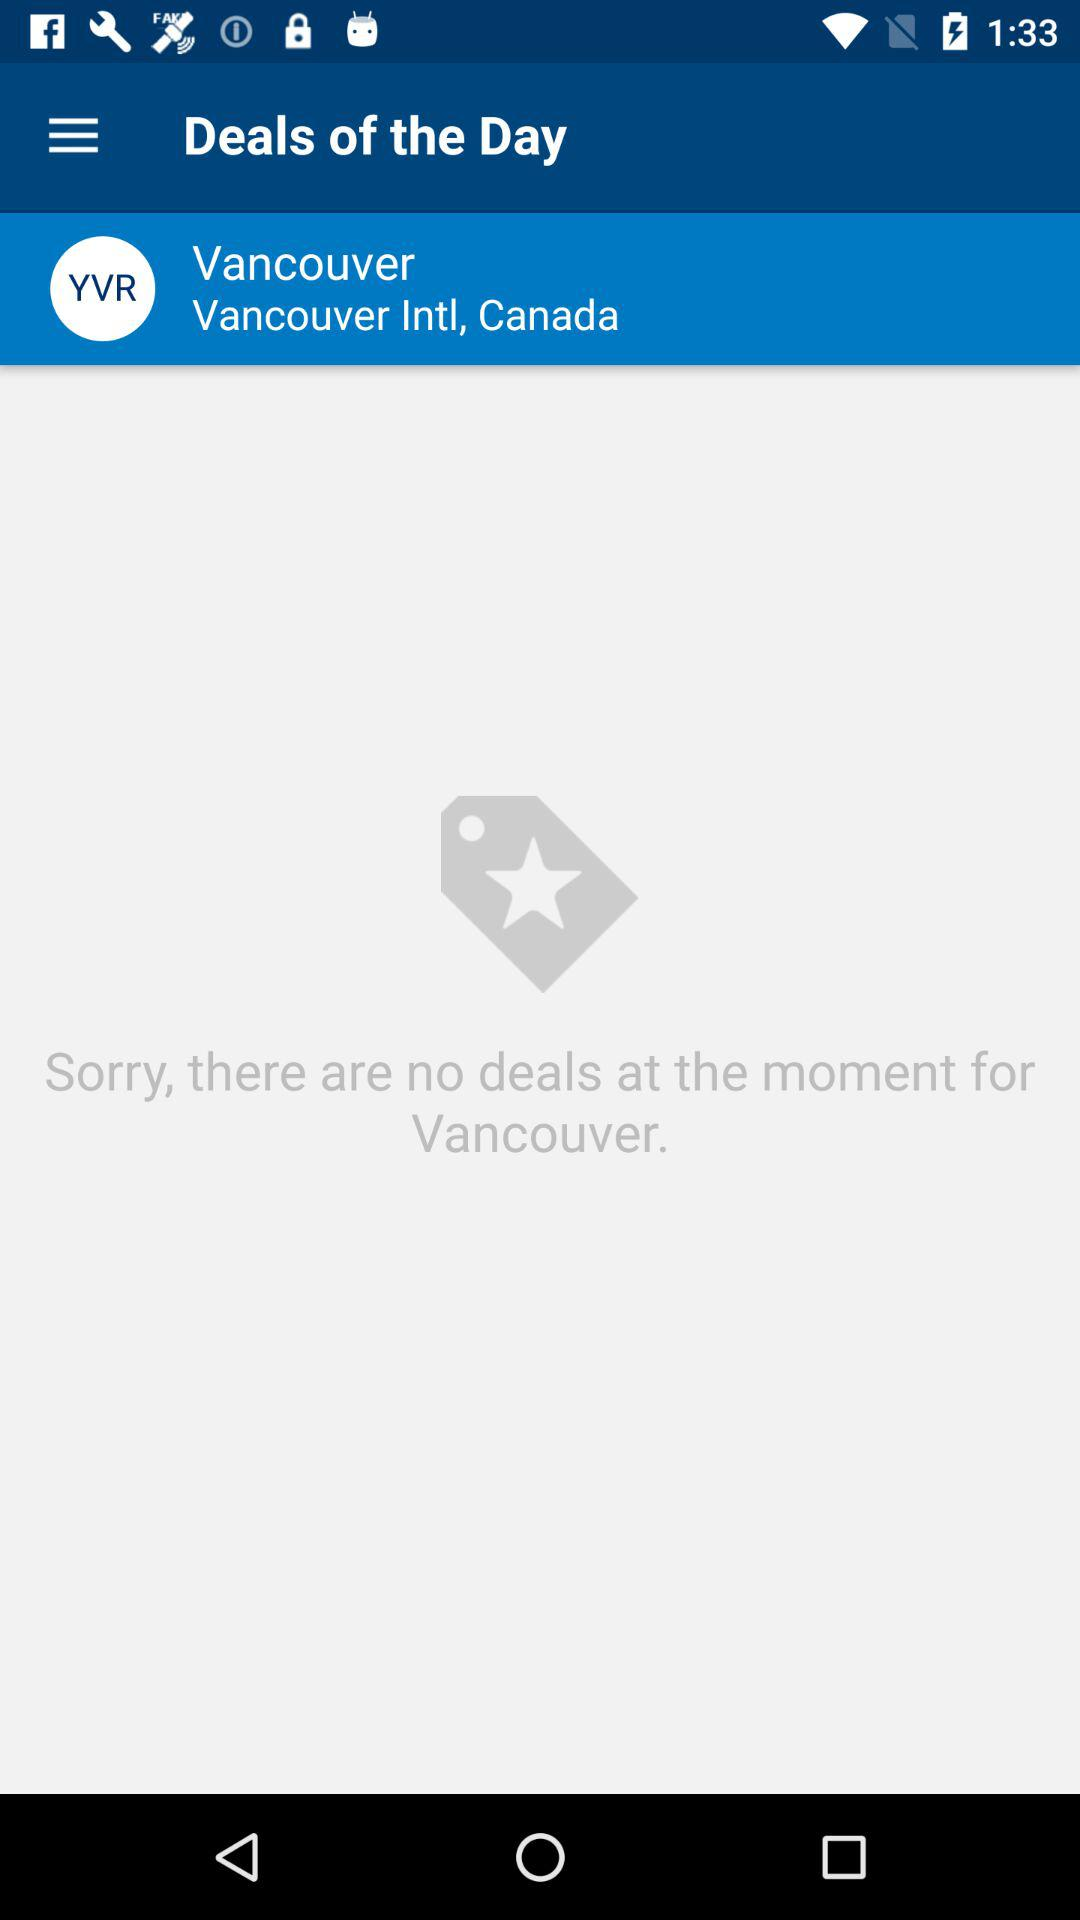What is the location? The location is Vancouver Intl, Canada. 